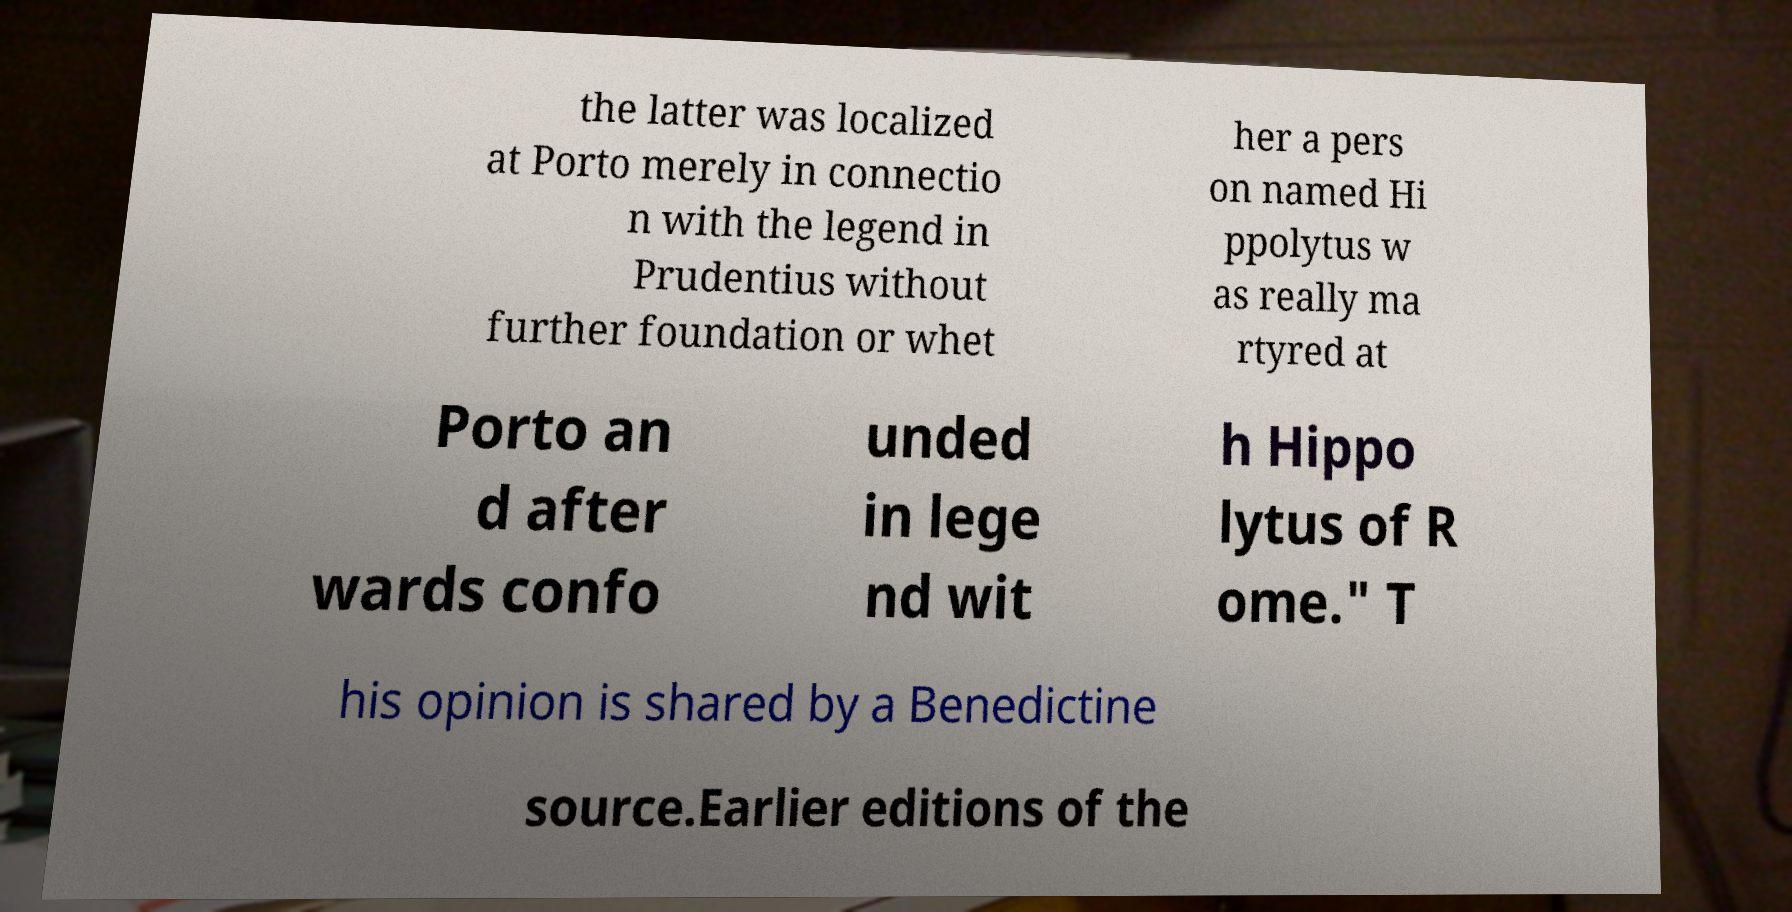What messages or text are displayed in this image? I need them in a readable, typed format. the latter was localized at Porto merely in connectio n with the legend in Prudentius without further foundation or whet her a pers on named Hi ppolytus w as really ma rtyred at Porto an d after wards confo unded in lege nd wit h Hippo lytus of R ome." T his opinion is shared by a Benedictine source.Earlier editions of the 